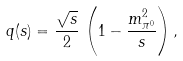Convert formula to latex. <formula><loc_0><loc_0><loc_500><loc_500>q ( s ) = \frac { \sqrt { s } } { 2 } \, \left ( 1 - \frac { m ^ { 2 } _ { \pi ^ { 0 } } } { s } \right ) ,</formula> 